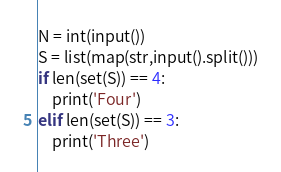Convert code to text. <code><loc_0><loc_0><loc_500><loc_500><_Python_>N = int(input())
S = list(map(str,input().split()))
if len(set(S)) == 4:
    print('Four')
elif len(set(S)) == 3:
    print('Three')</code> 